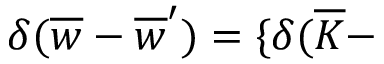<formula> <loc_0><loc_0><loc_500><loc_500>\delta ( \overline { w } - \overline { w } ^ { \prime } ) = \{ \delta ( \overline { K } -</formula> 